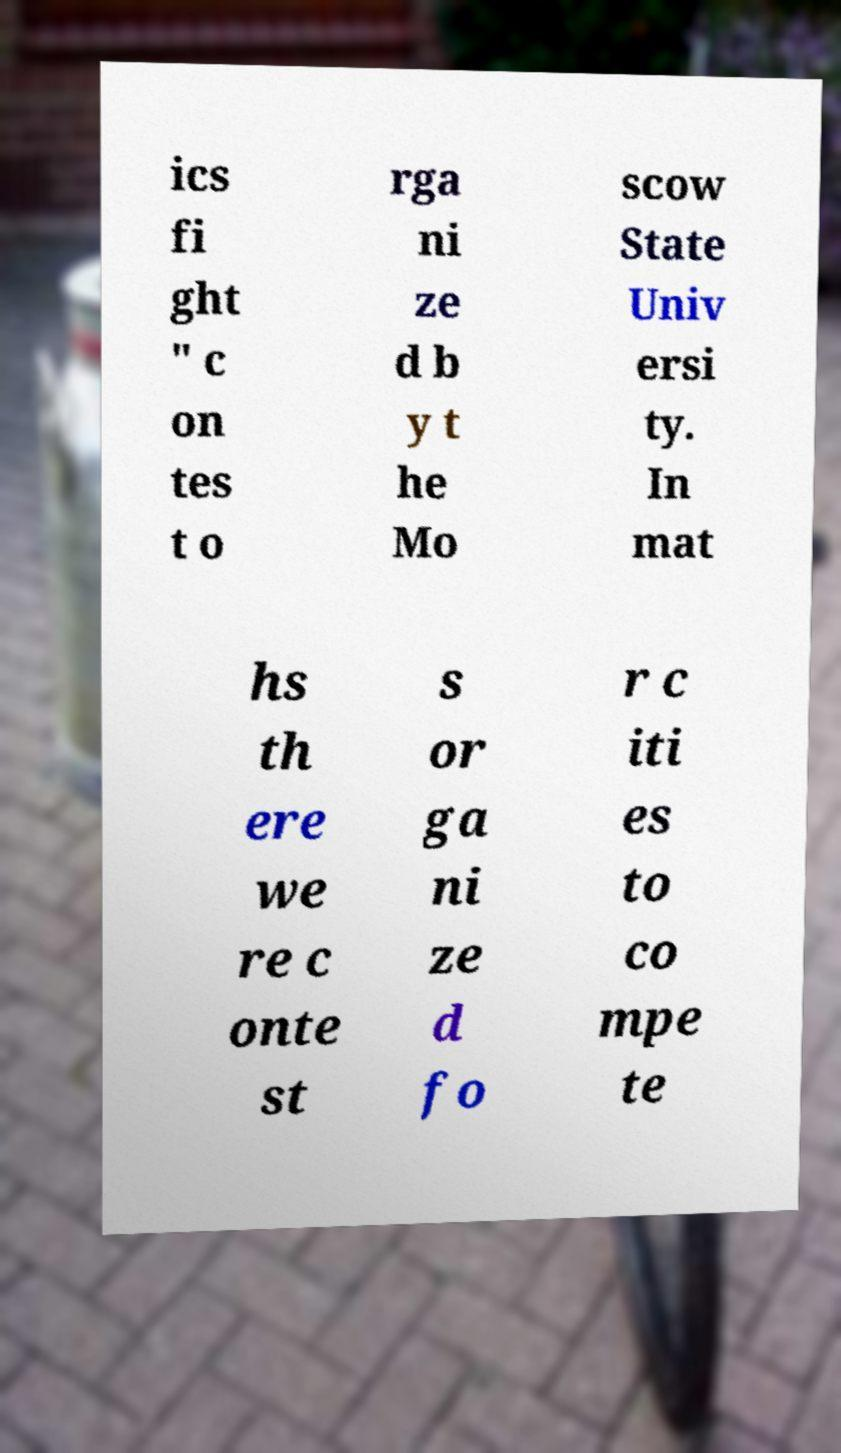I need the written content from this picture converted into text. Can you do that? ics fi ght " c on tes t o rga ni ze d b y t he Mo scow State Univ ersi ty. In mat hs th ere we re c onte st s or ga ni ze d fo r c iti es to co mpe te 